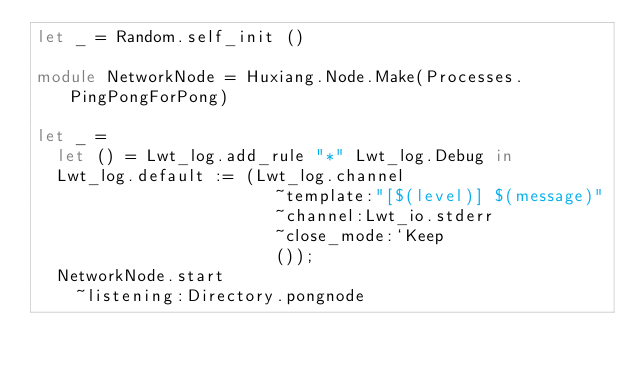Convert code to text. <code><loc_0><loc_0><loc_500><loc_500><_OCaml_>let _ = Random.self_init ()

module NetworkNode = Huxiang.Node.Make(Processes.PingPongForPong)

let _ =
  let () = Lwt_log.add_rule "*" Lwt_log.Debug in
  Lwt_log.default := (Lwt_log.channel
                        ~template:"[$(level)] $(message)"
                        ~channel:Lwt_io.stderr
                        ~close_mode:`Keep
                        ());
  NetworkNode.start
    ~listening:Directory.pongnode</code> 